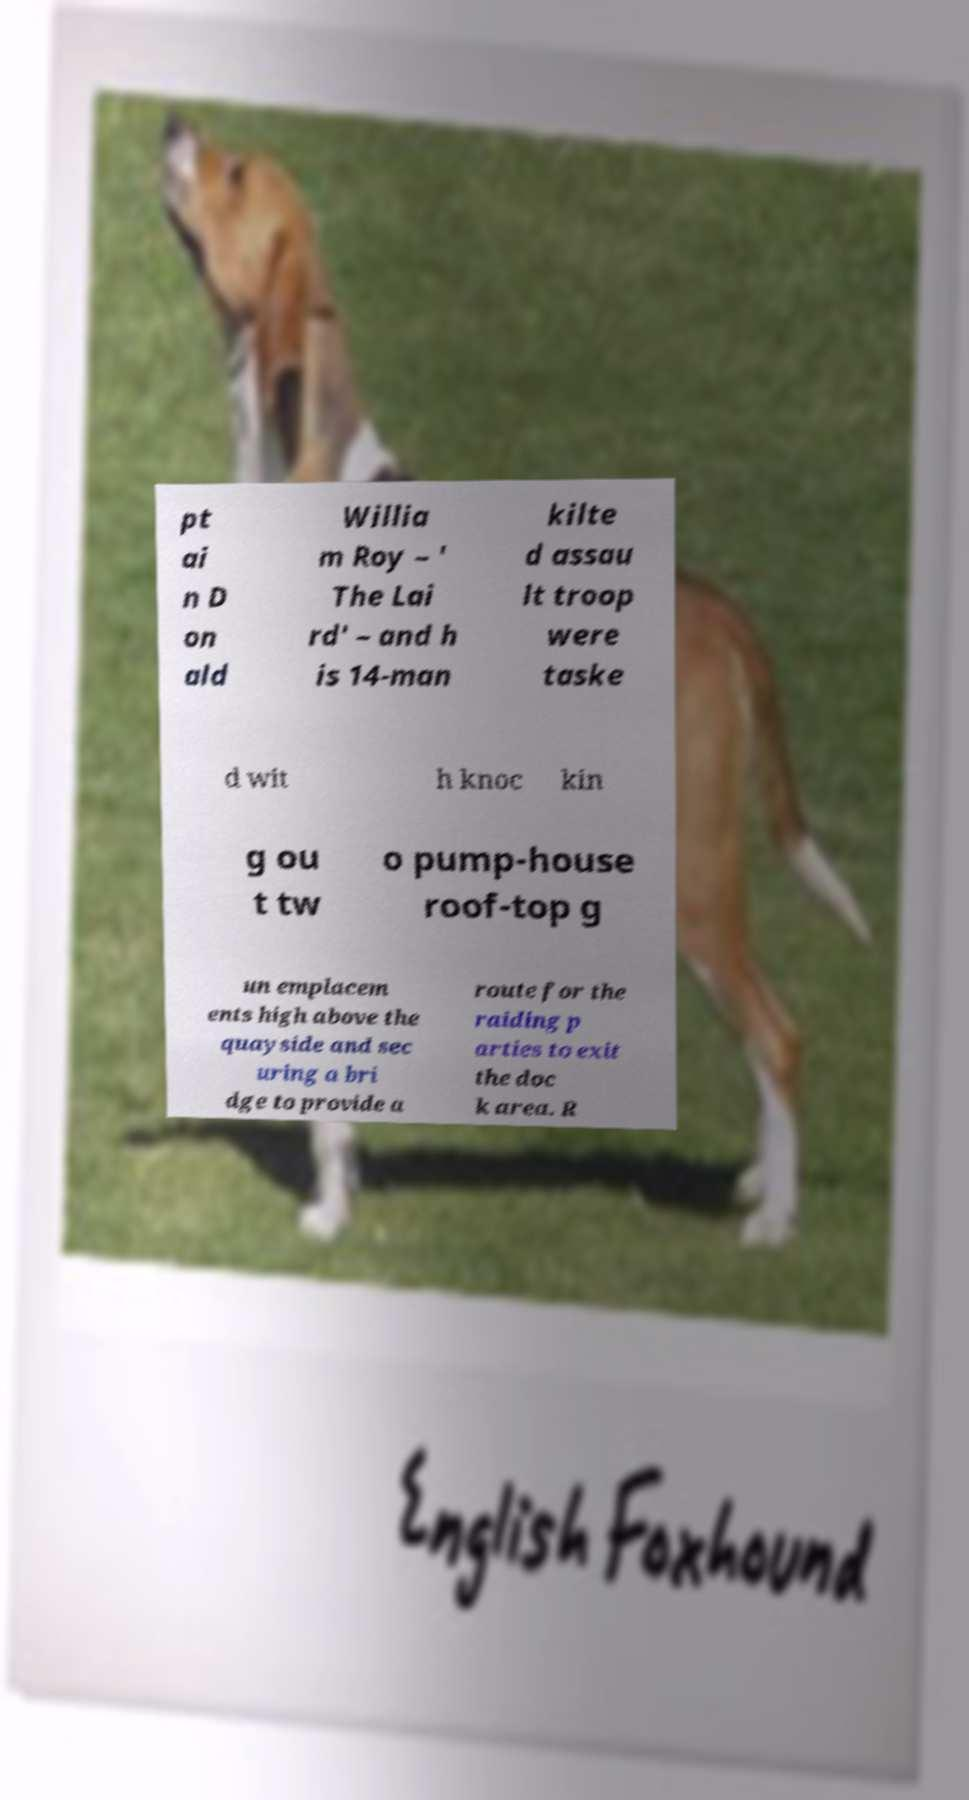What messages or text are displayed in this image? I need them in a readable, typed format. pt ai n D on ald Willia m Roy – ' The Lai rd' – and h is 14-man kilte d assau lt troop were taske d wit h knoc kin g ou t tw o pump-house roof-top g un emplacem ents high above the quayside and sec uring a bri dge to provide a route for the raiding p arties to exit the doc k area. R 